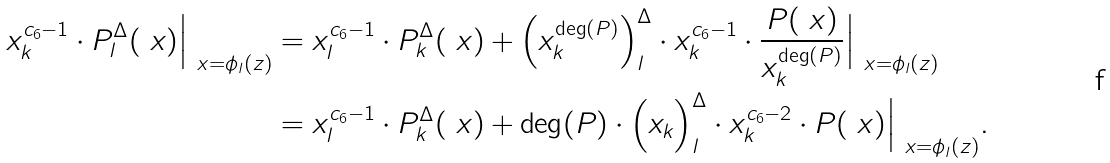Convert formula to latex. <formula><loc_0><loc_0><loc_500><loc_500>x _ { k } ^ { c _ { 6 } - 1 } \cdot P ^ { \Delta } _ { l } ( \ x ) \Big | _ { \ x = \phi _ { l } ( z ) } & = x _ { l } ^ { c _ { 6 } - 1 } \cdot P ^ { \Delta } _ { k } ( \ x ) + \Big ( x _ { k } ^ { \deg ( P ) } \Big ) _ { l } ^ { \Delta } \cdot x _ { k } ^ { c _ { 6 } - 1 } \cdot \frac { P ( \ x ) } { x _ { k } ^ { \deg ( P ) } } \Big | _ { \ x = \phi _ { l } ( z ) } \\ & = x _ { l } ^ { c _ { 6 } - 1 } \cdot P ^ { \Delta } _ { k } ( \ x ) + \deg ( P ) \cdot \Big ( x _ { k } \Big ) _ { l } ^ { \Delta } \cdot x _ { k } ^ { c _ { 6 } - 2 } \cdot P ( \ x ) \Big | _ { \ x = \phi _ { l } ( z ) } .</formula> 